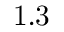<formula> <loc_0><loc_0><loc_500><loc_500>1 . 3</formula> 